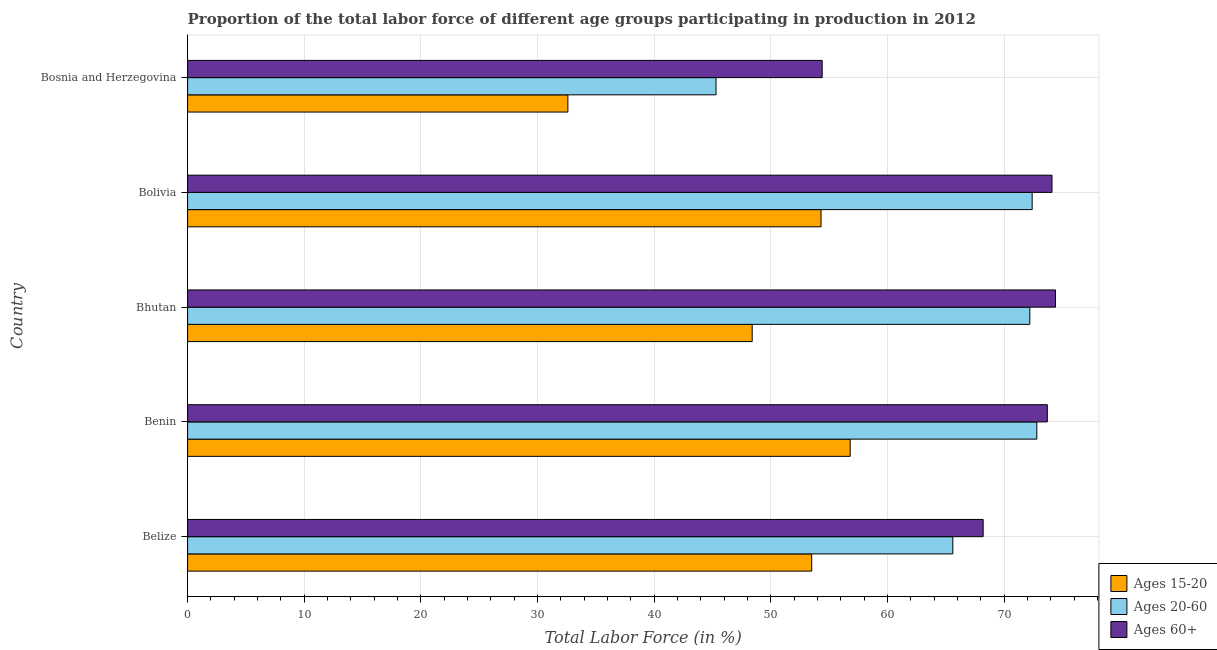Are the number of bars per tick equal to the number of legend labels?
Your response must be concise. Yes. How many bars are there on the 4th tick from the top?
Your answer should be very brief. 3. How many bars are there on the 5th tick from the bottom?
Offer a very short reply. 3. What is the percentage of labor force within the age group 15-20 in Bosnia and Herzegovina?
Give a very brief answer. 32.6. Across all countries, what is the maximum percentage of labor force above age 60?
Your answer should be compact. 74.4. Across all countries, what is the minimum percentage of labor force within the age group 15-20?
Your response must be concise. 32.6. In which country was the percentage of labor force within the age group 20-60 maximum?
Provide a succinct answer. Benin. In which country was the percentage of labor force within the age group 15-20 minimum?
Give a very brief answer. Bosnia and Herzegovina. What is the total percentage of labor force within the age group 20-60 in the graph?
Make the answer very short. 328.3. What is the difference between the percentage of labor force above age 60 in Benin and the percentage of labor force within the age group 15-20 in Bosnia and Herzegovina?
Give a very brief answer. 41.1. What is the average percentage of labor force within the age group 20-60 per country?
Offer a very short reply. 65.66. In how many countries, is the percentage of labor force within the age group 15-20 greater than 48 %?
Offer a terse response. 4. What is the ratio of the percentage of labor force within the age group 15-20 in Bhutan to that in Bolivia?
Provide a short and direct response. 0.89. What is the difference between the highest and the second highest percentage of labor force above age 60?
Ensure brevity in your answer.  0.3. What is the difference between the highest and the lowest percentage of labor force above age 60?
Offer a very short reply. 20. In how many countries, is the percentage of labor force above age 60 greater than the average percentage of labor force above age 60 taken over all countries?
Provide a short and direct response. 3. Is the sum of the percentage of labor force within the age group 20-60 in Belize and Bolivia greater than the maximum percentage of labor force above age 60 across all countries?
Your answer should be compact. Yes. What does the 1st bar from the top in Bolivia represents?
Provide a short and direct response. Ages 60+. What does the 3rd bar from the bottom in Benin represents?
Offer a terse response. Ages 60+. Are all the bars in the graph horizontal?
Make the answer very short. Yes. What is the difference between two consecutive major ticks on the X-axis?
Keep it short and to the point. 10. Are the values on the major ticks of X-axis written in scientific E-notation?
Provide a short and direct response. No. Does the graph contain any zero values?
Provide a short and direct response. No. How are the legend labels stacked?
Ensure brevity in your answer.  Vertical. What is the title of the graph?
Make the answer very short. Proportion of the total labor force of different age groups participating in production in 2012. What is the label or title of the X-axis?
Make the answer very short. Total Labor Force (in %). What is the Total Labor Force (in %) of Ages 15-20 in Belize?
Provide a succinct answer. 53.5. What is the Total Labor Force (in %) of Ages 20-60 in Belize?
Make the answer very short. 65.6. What is the Total Labor Force (in %) in Ages 60+ in Belize?
Keep it short and to the point. 68.2. What is the Total Labor Force (in %) in Ages 15-20 in Benin?
Offer a terse response. 56.8. What is the Total Labor Force (in %) of Ages 20-60 in Benin?
Ensure brevity in your answer.  72.8. What is the Total Labor Force (in %) of Ages 60+ in Benin?
Offer a very short reply. 73.7. What is the Total Labor Force (in %) of Ages 15-20 in Bhutan?
Offer a terse response. 48.4. What is the Total Labor Force (in %) of Ages 20-60 in Bhutan?
Your response must be concise. 72.2. What is the Total Labor Force (in %) in Ages 60+ in Bhutan?
Give a very brief answer. 74.4. What is the Total Labor Force (in %) in Ages 15-20 in Bolivia?
Make the answer very short. 54.3. What is the Total Labor Force (in %) of Ages 20-60 in Bolivia?
Provide a short and direct response. 72.4. What is the Total Labor Force (in %) in Ages 60+ in Bolivia?
Your answer should be compact. 74.1. What is the Total Labor Force (in %) of Ages 15-20 in Bosnia and Herzegovina?
Your answer should be compact. 32.6. What is the Total Labor Force (in %) of Ages 20-60 in Bosnia and Herzegovina?
Provide a short and direct response. 45.3. What is the Total Labor Force (in %) of Ages 60+ in Bosnia and Herzegovina?
Make the answer very short. 54.4. Across all countries, what is the maximum Total Labor Force (in %) in Ages 15-20?
Give a very brief answer. 56.8. Across all countries, what is the maximum Total Labor Force (in %) of Ages 20-60?
Keep it short and to the point. 72.8. Across all countries, what is the maximum Total Labor Force (in %) of Ages 60+?
Provide a succinct answer. 74.4. Across all countries, what is the minimum Total Labor Force (in %) of Ages 15-20?
Your response must be concise. 32.6. Across all countries, what is the minimum Total Labor Force (in %) in Ages 20-60?
Your answer should be very brief. 45.3. Across all countries, what is the minimum Total Labor Force (in %) in Ages 60+?
Provide a succinct answer. 54.4. What is the total Total Labor Force (in %) in Ages 15-20 in the graph?
Give a very brief answer. 245.6. What is the total Total Labor Force (in %) in Ages 20-60 in the graph?
Your answer should be compact. 328.3. What is the total Total Labor Force (in %) in Ages 60+ in the graph?
Ensure brevity in your answer.  344.8. What is the difference between the Total Labor Force (in %) in Ages 15-20 in Belize and that in Benin?
Your answer should be very brief. -3.3. What is the difference between the Total Labor Force (in %) of Ages 20-60 in Belize and that in Benin?
Ensure brevity in your answer.  -7.2. What is the difference between the Total Labor Force (in %) of Ages 15-20 in Belize and that in Bhutan?
Provide a succinct answer. 5.1. What is the difference between the Total Labor Force (in %) in Ages 60+ in Belize and that in Bhutan?
Give a very brief answer. -6.2. What is the difference between the Total Labor Force (in %) of Ages 15-20 in Belize and that in Bosnia and Herzegovina?
Your answer should be very brief. 20.9. What is the difference between the Total Labor Force (in %) of Ages 20-60 in Belize and that in Bosnia and Herzegovina?
Make the answer very short. 20.3. What is the difference between the Total Labor Force (in %) of Ages 15-20 in Benin and that in Bhutan?
Ensure brevity in your answer.  8.4. What is the difference between the Total Labor Force (in %) of Ages 20-60 in Benin and that in Bolivia?
Provide a short and direct response. 0.4. What is the difference between the Total Labor Force (in %) in Ages 60+ in Benin and that in Bolivia?
Provide a short and direct response. -0.4. What is the difference between the Total Labor Force (in %) in Ages 15-20 in Benin and that in Bosnia and Herzegovina?
Provide a succinct answer. 24.2. What is the difference between the Total Labor Force (in %) in Ages 20-60 in Benin and that in Bosnia and Herzegovina?
Give a very brief answer. 27.5. What is the difference between the Total Labor Force (in %) in Ages 60+ in Benin and that in Bosnia and Herzegovina?
Offer a terse response. 19.3. What is the difference between the Total Labor Force (in %) of Ages 15-20 in Bhutan and that in Bolivia?
Your answer should be very brief. -5.9. What is the difference between the Total Labor Force (in %) of Ages 60+ in Bhutan and that in Bolivia?
Offer a terse response. 0.3. What is the difference between the Total Labor Force (in %) in Ages 15-20 in Bhutan and that in Bosnia and Herzegovina?
Provide a succinct answer. 15.8. What is the difference between the Total Labor Force (in %) of Ages 20-60 in Bhutan and that in Bosnia and Herzegovina?
Offer a very short reply. 26.9. What is the difference between the Total Labor Force (in %) of Ages 60+ in Bhutan and that in Bosnia and Herzegovina?
Offer a terse response. 20. What is the difference between the Total Labor Force (in %) of Ages 15-20 in Bolivia and that in Bosnia and Herzegovina?
Provide a short and direct response. 21.7. What is the difference between the Total Labor Force (in %) of Ages 20-60 in Bolivia and that in Bosnia and Herzegovina?
Provide a succinct answer. 27.1. What is the difference between the Total Labor Force (in %) of Ages 15-20 in Belize and the Total Labor Force (in %) of Ages 20-60 in Benin?
Your answer should be very brief. -19.3. What is the difference between the Total Labor Force (in %) of Ages 15-20 in Belize and the Total Labor Force (in %) of Ages 60+ in Benin?
Your answer should be very brief. -20.2. What is the difference between the Total Labor Force (in %) in Ages 15-20 in Belize and the Total Labor Force (in %) in Ages 20-60 in Bhutan?
Keep it short and to the point. -18.7. What is the difference between the Total Labor Force (in %) of Ages 15-20 in Belize and the Total Labor Force (in %) of Ages 60+ in Bhutan?
Make the answer very short. -20.9. What is the difference between the Total Labor Force (in %) in Ages 20-60 in Belize and the Total Labor Force (in %) in Ages 60+ in Bhutan?
Provide a succinct answer. -8.8. What is the difference between the Total Labor Force (in %) of Ages 15-20 in Belize and the Total Labor Force (in %) of Ages 20-60 in Bolivia?
Offer a terse response. -18.9. What is the difference between the Total Labor Force (in %) in Ages 15-20 in Belize and the Total Labor Force (in %) in Ages 60+ in Bolivia?
Offer a terse response. -20.6. What is the difference between the Total Labor Force (in %) in Ages 20-60 in Belize and the Total Labor Force (in %) in Ages 60+ in Bolivia?
Keep it short and to the point. -8.5. What is the difference between the Total Labor Force (in %) in Ages 15-20 in Belize and the Total Labor Force (in %) in Ages 20-60 in Bosnia and Herzegovina?
Offer a terse response. 8.2. What is the difference between the Total Labor Force (in %) in Ages 15-20 in Belize and the Total Labor Force (in %) in Ages 60+ in Bosnia and Herzegovina?
Offer a terse response. -0.9. What is the difference between the Total Labor Force (in %) of Ages 15-20 in Benin and the Total Labor Force (in %) of Ages 20-60 in Bhutan?
Offer a very short reply. -15.4. What is the difference between the Total Labor Force (in %) in Ages 15-20 in Benin and the Total Labor Force (in %) in Ages 60+ in Bhutan?
Make the answer very short. -17.6. What is the difference between the Total Labor Force (in %) of Ages 20-60 in Benin and the Total Labor Force (in %) of Ages 60+ in Bhutan?
Offer a very short reply. -1.6. What is the difference between the Total Labor Force (in %) of Ages 15-20 in Benin and the Total Labor Force (in %) of Ages 20-60 in Bolivia?
Offer a terse response. -15.6. What is the difference between the Total Labor Force (in %) of Ages 15-20 in Benin and the Total Labor Force (in %) of Ages 60+ in Bolivia?
Ensure brevity in your answer.  -17.3. What is the difference between the Total Labor Force (in %) in Ages 20-60 in Benin and the Total Labor Force (in %) in Ages 60+ in Bolivia?
Ensure brevity in your answer.  -1.3. What is the difference between the Total Labor Force (in %) in Ages 15-20 in Bhutan and the Total Labor Force (in %) in Ages 20-60 in Bolivia?
Your answer should be very brief. -24. What is the difference between the Total Labor Force (in %) of Ages 15-20 in Bhutan and the Total Labor Force (in %) of Ages 60+ in Bolivia?
Offer a very short reply. -25.7. What is the difference between the Total Labor Force (in %) of Ages 20-60 in Bhutan and the Total Labor Force (in %) of Ages 60+ in Bolivia?
Keep it short and to the point. -1.9. What is the difference between the Total Labor Force (in %) of Ages 20-60 in Bhutan and the Total Labor Force (in %) of Ages 60+ in Bosnia and Herzegovina?
Keep it short and to the point. 17.8. What is the difference between the Total Labor Force (in %) in Ages 15-20 in Bolivia and the Total Labor Force (in %) in Ages 20-60 in Bosnia and Herzegovina?
Offer a very short reply. 9. What is the difference between the Total Labor Force (in %) in Ages 20-60 in Bolivia and the Total Labor Force (in %) in Ages 60+ in Bosnia and Herzegovina?
Provide a succinct answer. 18. What is the average Total Labor Force (in %) of Ages 15-20 per country?
Provide a succinct answer. 49.12. What is the average Total Labor Force (in %) in Ages 20-60 per country?
Keep it short and to the point. 65.66. What is the average Total Labor Force (in %) of Ages 60+ per country?
Your answer should be very brief. 68.96. What is the difference between the Total Labor Force (in %) in Ages 15-20 and Total Labor Force (in %) in Ages 20-60 in Belize?
Your answer should be compact. -12.1. What is the difference between the Total Labor Force (in %) in Ages 15-20 and Total Labor Force (in %) in Ages 60+ in Belize?
Offer a terse response. -14.7. What is the difference between the Total Labor Force (in %) in Ages 15-20 and Total Labor Force (in %) in Ages 60+ in Benin?
Your answer should be very brief. -16.9. What is the difference between the Total Labor Force (in %) of Ages 20-60 and Total Labor Force (in %) of Ages 60+ in Benin?
Offer a terse response. -0.9. What is the difference between the Total Labor Force (in %) of Ages 15-20 and Total Labor Force (in %) of Ages 20-60 in Bhutan?
Your answer should be very brief. -23.8. What is the difference between the Total Labor Force (in %) in Ages 15-20 and Total Labor Force (in %) in Ages 60+ in Bhutan?
Offer a very short reply. -26. What is the difference between the Total Labor Force (in %) in Ages 20-60 and Total Labor Force (in %) in Ages 60+ in Bhutan?
Give a very brief answer. -2.2. What is the difference between the Total Labor Force (in %) of Ages 15-20 and Total Labor Force (in %) of Ages 20-60 in Bolivia?
Your answer should be very brief. -18.1. What is the difference between the Total Labor Force (in %) of Ages 15-20 and Total Labor Force (in %) of Ages 60+ in Bolivia?
Make the answer very short. -19.8. What is the difference between the Total Labor Force (in %) in Ages 20-60 and Total Labor Force (in %) in Ages 60+ in Bolivia?
Your answer should be compact. -1.7. What is the difference between the Total Labor Force (in %) in Ages 15-20 and Total Labor Force (in %) in Ages 60+ in Bosnia and Herzegovina?
Ensure brevity in your answer.  -21.8. What is the difference between the Total Labor Force (in %) of Ages 20-60 and Total Labor Force (in %) of Ages 60+ in Bosnia and Herzegovina?
Offer a terse response. -9.1. What is the ratio of the Total Labor Force (in %) in Ages 15-20 in Belize to that in Benin?
Offer a terse response. 0.94. What is the ratio of the Total Labor Force (in %) of Ages 20-60 in Belize to that in Benin?
Provide a succinct answer. 0.9. What is the ratio of the Total Labor Force (in %) in Ages 60+ in Belize to that in Benin?
Offer a terse response. 0.93. What is the ratio of the Total Labor Force (in %) of Ages 15-20 in Belize to that in Bhutan?
Keep it short and to the point. 1.11. What is the ratio of the Total Labor Force (in %) of Ages 20-60 in Belize to that in Bhutan?
Keep it short and to the point. 0.91. What is the ratio of the Total Labor Force (in %) of Ages 60+ in Belize to that in Bhutan?
Your response must be concise. 0.92. What is the ratio of the Total Labor Force (in %) of Ages 20-60 in Belize to that in Bolivia?
Offer a terse response. 0.91. What is the ratio of the Total Labor Force (in %) of Ages 60+ in Belize to that in Bolivia?
Your answer should be very brief. 0.92. What is the ratio of the Total Labor Force (in %) of Ages 15-20 in Belize to that in Bosnia and Herzegovina?
Your response must be concise. 1.64. What is the ratio of the Total Labor Force (in %) of Ages 20-60 in Belize to that in Bosnia and Herzegovina?
Offer a very short reply. 1.45. What is the ratio of the Total Labor Force (in %) of Ages 60+ in Belize to that in Bosnia and Herzegovina?
Keep it short and to the point. 1.25. What is the ratio of the Total Labor Force (in %) of Ages 15-20 in Benin to that in Bhutan?
Your answer should be very brief. 1.17. What is the ratio of the Total Labor Force (in %) of Ages 20-60 in Benin to that in Bhutan?
Your response must be concise. 1.01. What is the ratio of the Total Labor Force (in %) of Ages 60+ in Benin to that in Bhutan?
Offer a very short reply. 0.99. What is the ratio of the Total Labor Force (in %) of Ages 15-20 in Benin to that in Bolivia?
Offer a terse response. 1.05. What is the ratio of the Total Labor Force (in %) in Ages 20-60 in Benin to that in Bolivia?
Make the answer very short. 1.01. What is the ratio of the Total Labor Force (in %) of Ages 15-20 in Benin to that in Bosnia and Herzegovina?
Your answer should be compact. 1.74. What is the ratio of the Total Labor Force (in %) in Ages 20-60 in Benin to that in Bosnia and Herzegovina?
Ensure brevity in your answer.  1.61. What is the ratio of the Total Labor Force (in %) of Ages 60+ in Benin to that in Bosnia and Herzegovina?
Offer a terse response. 1.35. What is the ratio of the Total Labor Force (in %) of Ages 15-20 in Bhutan to that in Bolivia?
Keep it short and to the point. 0.89. What is the ratio of the Total Labor Force (in %) in Ages 20-60 in Bhutan to that in Bolivia?
Your response must be concise. 1. What is the ratio of the Total Labor Force (in %) of Ages 60+ in Bhutan to that in Bolivia?
Offer a very short reply. 1. What is the ratio of the Total Labor Force (in %) in Ages 15-20 in Bhutan to that in Bosnia and Herzegovina?
Your response must be concise. 1.48. What is the ratio of the Total Labor Force (in %) of Ages 20-60 in Bhutan to that in Bosnia and Herzegovina?
Ensure brevity in your answer.  1.59. What is the ratio of the Total Labor Force (in %) in Ages 60+ in Bhutan to that in Bosnia and Herzegovina?
Your response must be concise. 1.37. What is the ratio of the Total Labor Force (in %) in Ages 15-20 in Bolivia to that in Bosnia and Herzegovina?
Your answer should be very brief. 1.67. What is the ratio of the Total Labor Force (in %) in Ages 20-60 in Bolivia to that in Bosnia and Herzegovina?
Your answer should be compact. 1.6. What is the ratio of the Total Labor Force (in %) of Ages 60+ in Bolivia to that in Bosnia and Herzegovina?
Keep it short and to the point. 1.36. What is the difference between the highest and the second highest Total Labor Force (in %) in Ages 60+?
Make the answer very short. 0.3. What is the difference between the highest and the lowest Total Labor Force (in %) in Ages 15-20?
Ensure brevity in your answer.  24.2. What is the difference between the highest and the lowest Total Labor Force (in %) in Ages 20-60?
Ensure brevity in your answer.  27.5. 